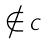Convert formula to latex. <formula><loc_0><loc_0><loc_500><loc_500>\notin C</formula> 